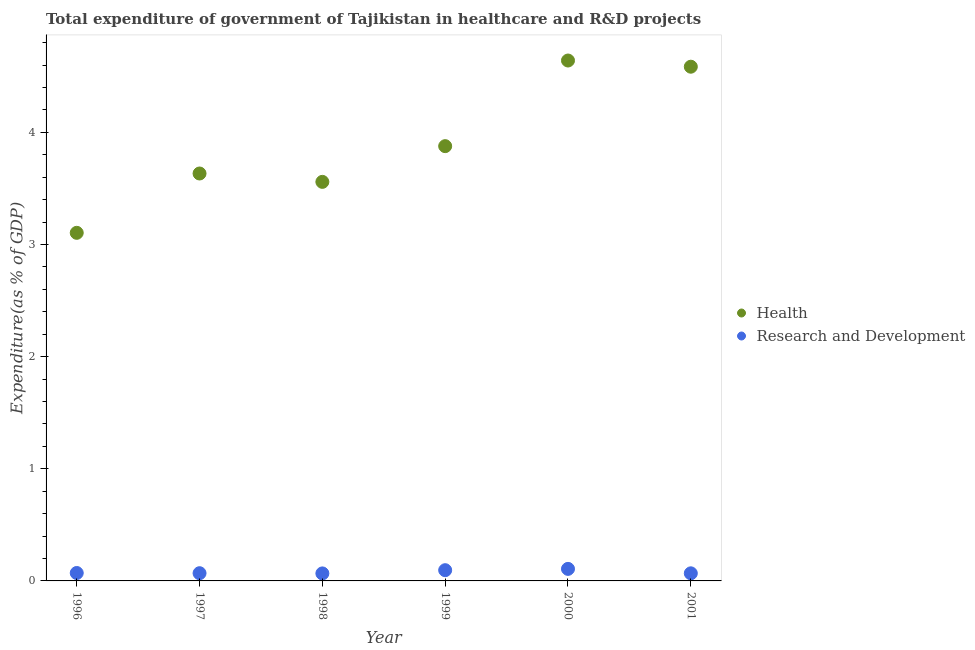Is the number of dotlines equal to the number of legend labels?
Ensure brevity in your answer.  Yes. What is the expenditure in healthcare in 1999?
Your answer should be very brief. 3.88. Across all years, what is the maximum expenditure in healthcare?
Provide a succinct answer. 4.64. Across all years, what is the minimum expenditure in healthcare?
Offer a very short reply. 3.1. In which year was the expenditure in healthcare maximum?
Your answer should be very brief. 2000. What is the total expenditure in healthcare in the graph?
Your answer should be very brief. 23.4. What is the difference between the expenditure in healthcare in 1997 and that in 1999?
Your answer should be very brief. -0.24. What is the difference between the expenditure in healthcare in 2001 and the expenditure in r&d in 2000?
Make the answer very short. 4.48. What is the average expenditure in r&d per year?
Keep it short and to the point. 0.08. In the year 2000, what is the difference between the expenditure in healthcare and expenditure in r&d?
Provide a succinct answer. 4.53. In how many years, is the expenditure in r&d greater than 2 %?
Offer a terse response. 0. What is the ratio of the expenditure in r&d in 1997 to that in 2000?
Your answer should be very brief. 0.64. What is the difference between the highest and the second highest expenditure in healthcare?
Offer a very short reply. 0.06. What is the difference between the highest and the lowest expenditure in healthcare?
Your response must be concise. 1.54. In how many years, is the expenditure in healthcare greater than the average expenditure in healthcare taken over all years?
Offer a terse response. 2. What is the difference between two consecutive major ticks on the Y-axis?
Keep it short and to the point. 1. Does the graph contain grids?
Your response must be concise. No. How many legend labels are there?
Keep it short and to the point. 2. How are the legend labels stacked?
Your response must be concise. Vertical. What is the title of the graph?
Provide a short and direct response. Total expenditure of government of Tajikistan in healthcare and R&D projects. Does "Lowest 20% of population" appear as one of the legend labels in the graph?
Make the answer very short. No. What is the label or title of the Y-axis?
Your answer should be compact. Expenditure(as % of GDP). What is the Expenditure(as % of GDP) of Health in 1996?
Give a very brief answer. 3.1. What is the Expenditure(as % of GDP) of Research and Development in 1996?
Provide a succinct answer. 0.07. What is the Expenditure(as % of GDP) in Health in 1997?
Offer a terse response. 3.63. What is the Expenditure(as % of GDP) in Research and Development in 1997?
Offer a very short reply. 0.07. What is the Expenditure(as % of GDP) in Health in 1998?
Keep it short and to the point. 3.56. What is the Expenditure(as % of GDP) in Research and Development in 1998?
Ensure brevity in your answer.  0.07. What is the Expenditure(as % of GDP) of Health in 1999?
Your answer should be compact. 3.88. What is the Expenditure(as % of GDP) in Research and Development in 1999?
Ensure brevity in your answer.  0.1. What is the Expenditure(as % of GDP) in Health in 2000?
Make the answer very short. 4.64. What is the Expenditure(as % of GDP) in Research and Development in 2000?
Provide a short and direct response. 0.11. What is the Expenditure(as % of GDP) of Health in 2001?
Make the answer very short. 4.59. What is the Expenditure(as % of GDP) in Research and Development in 2001?
Your answer should be compact. 0.07. Across all years, what is the maximum Expenditure(as % of GDP) of Health?
Ensure brevity in your answer.  4.64. Across all years, what is the maximum Expenditure(as % of GDP) of Research and Development?
Provide a succinct answer. 0.11. Across all years, what is the minimum Expenditure(as % of GDP) in Health?
Give a very brief answer. 3.1. Across all years, what is the minimum Expenditure(as % of GDP) in Research and Development?
Your answer should be very brief. 0.07. What is the total Expenditure(as % of GDP) in Health in the graph?
Keep it short and to the point. 23.4. What is the total Expenditure(as % of GDP) in Research and Development in the graph?
Make the answer very short. 0.48. What is the difference between the Expenditure(as % of GDP) of Health in 1996 and that in 1997?
Your answer should be very brief. -0.53. What is the difference between the Expenditure(as % of GDP) in Research and Development in 1996 and that in 1997?
Your answer should be compact. 0. What is the difference between the Expenditure(as % of GDP) in Health in 1996 and that in 1998?
Keep it short and to the point. -0.45. What is the difference between the Expenditure(as % of GDP) in Research and Development in 1996 and that in 1998?
Your answer should be very brief. 0. What is the difference between the Expenditure(as % of GDP) in Health in 1996 and that in 1999?
Your response must be concise. -0.77. What is the difference between the Expenditure(as % of GDP) in Research and Development in 1996 and that in 1999?
Provide a succinct answer. -0.03. What is the difference between the Expenditure(as % of GDP) in Health in 1996 and that in 2000?
Give a very brief answer. -1.54. What is the difference between the Expenditure(as % of GDP) in Research and Development in 1996 and that in 2000?
Ensure brevity in your answer.  -0.04. What is the difference between the Expenditure(as % of GDP) of Health in 1996 and that in 2001?
Your answer should be compact. -1.48. What is the difference between the Expenditure(as % of GDP) in Research and Development in 1996 and that in 2001?
Give a very brief answer. 0. What is the difference between the Expenditure(as % of GDP) of Health in 1997 and that in 1998?
Ensure brevity in your answer.  0.07. What is the difference between the Expenditure(as % of GDP) of Research and Development in 1997 and that in 1998?
Keep it short and to the point. 0. What is the difference between the Expenditure(as % of GDP) of Health in 1997 and that in 1999?
Ensure brevity in your answer.  -0.24. What is the difference between the Expenditure(as % of GDP) of Research and Development in 1997 and that in 1999?
Provide a short and direct response. -0.03. What is the difference between the Expenditure(as % of GDP) of Health in 1997 and that in 2000?
Provide a succinct answer. -1.01. What is the difference between the Expenditure(as % of GDP) in Research and Development in 1997 and that in 2000?
Keep it short and to the point. -0.04. What is the difference between the Expenditure(as % of GDP) of Health in 1997 and that in 2001?
Ensure brevity in your answer.  -0.95. What is the difference between the Expenditure(as % of GDP) of Research and Development in 1997 and that in 2001?
Your answer should be compact. 0. What is the difference between the Expenditure(as % of GDP) of Health in 1998 and that in 1999?
Give a very brief answer. -0.32. What is the difference between the Expenditure(as % of GDP) of Research and Development in 1998 and that in 1999?
Your answer should be very brief. -0.03. What is the difference between the Expenditure(as % of GDP) in Health in 1998 and that in 2000?
Offer a very short reply. -1.08. What is the difference between the Expenditure(as % of GDP) in Research and Development in 1998 and that in 2000?
Give a very brief answer. -0.04. What is the difference between the Expenditure(as % of GDP) of Health in 1998 and that in 2001?
Ensure brevity in your answer.  -1.03. What is the difference between the Expenditure(as % of GDP) in Research and Development in 1998 and that in 2001?
Provide a short and direct response. -0. What is the difference between the Expenditure(as % of GDP) of Health in 1999 and that in 2000?
Your answer should be compact. -0.76. What is the difference between the Expenditure(as % of GDP) of Research and Development in 1999 and that in 2000?
Offer a very short reply. -0.01. What is the difference between the Expenditure(as % of GDP) of Health in 1999 and that in 2001?
Keep it short and to the point. -0.71. What is the difference between the Expenditure(as % of GDP) in Research and Development in 1999 and that in 2001?
Make the answer very short. 0.03. What is the difference between the Expenditure(as % of GDP) of Health in 2000 and that in 2001?
Offer a very short reply. 0.06. What is the difference between the Expenditure(as % of GDP) in Research and Development in 2000 and that in 2001?
Provide a succinct answer. 0.04. What is the difference between the Expenditure(as % of GDP) in Health in 1996 and the Expenditure(as % of GDP) in Research and Development in 1997?
Provide a short and direct response. 3.04. What is the difference between the Expenditure(as % of GDP) of Health in 1996 and the Expenditure(as % of GDP) of Research and Development in 1998?
Your answer should be very brief. 3.04. What is the difference between the Expenditure(as % of GDP) in Health in 1996 and the Expenditure(as % of GDP) in Research and Development in 1999?
Ensure brevity in your answer.  3.01. What is the difference between the Expenditure(as % of GDP) of Health in 1996 and the Expenditure(as % of GDP) of Research and Development in 2000?
Make the answer very short. 3. What is the difference between the Expenditure(as % of GDP) of Health in 1996 and the Expenditure(as % of GDP) of Research and Development in 2001?
Ensure brevity in your answer.  3.04. What is the difference between the Expenditure(as % of GDP) in Health in 1997 and the Expenditure(as % of GDP) in Research and Development in 1998?
Ensure brevity in your answer.  3.57. What is the difference between the Expenditure(as % of GDP) in Health in 1997 and the Expenditure(as % of GDP) in Research and Development in 1999?
Keep it short and to the point. 3.54. What is the difference between the Expenditure(as % of GDP) of Health in 1997 and the Expenditure(as % of GDP) of Research and Development in 2000?
Provide a succinct answer. 3.53. What is the difference between the Expenditure(as % of GDP) of Health in 1997 and the Expenditure(as % of GDP) of Research and Development in 2001?
Your answer should be compact. 3.57. What is the difference between the Expenditure(as % of GDP) in Health in 1998 and the Expenditure(as % of GDP) in Research and Development in 1999?
Offer a very short reply. 3.46. What is the difference between the Expenditure(as % of GDP) in Health in 1998 and the Expenditure(as % of GDP) in Research and Development in 2000?
Make the answer very short. 3.45. What is the difference between the Expenditure(as % of GDP) in Health in 1998 and the Expenditure(as % of GDP) in Research and Development in 2001?
Provide a succinct answer. 3.49. What is the difference between the Expenditure(as % of GDP) of Health in 1999 and the Expenditure(as % of GDP) of Research and Development in 2000?
Make the answer very short. 3.77. What is the difference between the Expenditure(as % of GDP) of Health in 1999 and the Expenditure(as % of GDP) of Research and Development in 2001?
Make the answer very short. 3.81. What is the difference between the Expenditure(as % of GDP) of Health in 2000 and the Expenditure(as % of GDP) of Research and Development in 2001?
Offer a terse response. 4.57. What is the average Expenditure(as % of GDP) of Health per year?
Your answer should be compact. 3.9. What is the average Expenditure(as % of GDP) in Research and Development per year?
Provide a short and direct response. 0.08. In the year 1996, what is the difference between the Expenditure(as % of GDP) of Health and Expenditure(as % of GDP) of Research and Development?
Offer a terse response. 3.03. In the year 1997, what is the difference between the Expenditure(as % of GDP) of Health and Expenditure(as % of GDP) of Research and Development?
Provide a succinct answer. 3.56. In the year 1998, what is the difference between the Expenditure(as % of GDP) in Health and Expenditure(as % of GDP) in Research and Development?
Keep it short and to the point. 3.49. In the year 1999, what is the difference between the Expenditure(as % of GDP) of Health and Expenditure(as % of GDP) of Research and Development?
Your response must be concise. 3.78. In the year 2000, what is the difference between the Expenditure(as % of GDP) of Health and Expenditure(as % of GDP) of Research and Development?
Your answer should be very brief. 4.53. In the year 2001, what is the difference between the Expenditure(as % of GDP) in Health and Expenditure(as % of GDP) in Research and Development?
Offer a terse response. 4.52. What is the ratio of the Expenditure(as % of GDP) in Health in 1996 to that in 1997?
Give a very brief answer. 0.85. What is the ratio of the Expenditure(as % of GDP) of Research and Development in 1996 to that in 1997?
Your answer should be compact. 1.03. What is the ratio of the Expenditure(as % of GDP) in Health in 1996 to that in 1998?
Your answer should be compact. 0.87. What is the ratio of the Expenditure(as % of GDP) in Research and Development in 1996 to that in 1998?
Provide a short and direct response. 1.06. What is the ratio of the Expenditure(as % of GDP) in Health in 1996 to that in 1999?
Your answer should be very brief. 0.8. What is the ratio of the Expenditure(as % of GDP) of Research and Development in 1996 to that in 1999?
Give a very brief answer. 0.74. What is the ratio of the Expenditure(as % of GDP) in Health in 1996 to that in 2000?
Your answer should be very brief. 0.67. What is the ratio of the Expenditure(as % of GDP) in Research and Development in 1996 to that in 2000?
Your response must be concise. 0.66. What is the ratio of the Expenditure(as % of GDP) of Health in 1996 to that in 2001?
Ensure brevity in your answer.  0.68. What is the ratio of the Expenditure(as % of GDP) in Research and Development in 1996 to that in 2001?
Offer a very short reply. 1.04. What is the ratio of the Expenditure(as % of GDP) in Research and Development in 1997 to that in 1998?
Ensure brevity in your answer.  1.03. What is the ratio of the Expenditure(as % of GDP) in Health in 1997 to that in 1999?
Offer a very short reply. 0.94. What is the ratio of the Expenditure(as % of GDP) of Research and Development in 1997 to that in 1999?
Your response must be concise. 0.72. What is the ratio of the Expenditure(as % of GDP) in Health in 1997 to that in 2000?
Ensure brevity in your answer.  0.78. What is the ratio of the Expenditure(as % of GDP) in Research and Development in 1997 to that in 2000?
Your response must be concise. 0.64. What is the ratio of the Expenditure(as % of GDP) of Health in 1997 to that in 2001?
Ensure brevity in your answer.  0.79. What is the ratio of the Expenditure(as % of GDP) in Research and Development in 1997 to that in 2001?
Provide a short and direct response. 1.02. What is the ratio of the Expenditure(as % of GDP) of Health in 1998 to that in 1999?
Give a very brief answer. 0.92. What is the ratio of the Expenditure(as % of GDP) of Research and Development in 1998 to that in 1999?
Your answer should be compact. 0.7. What is the ratio of the Expenditure(as % of GDP) of Health in 1998 to that in 2000?
Ensure brevity in your answer.  0.77. What is the ratio of the Expenditure(as % of GDP) of Research and Development in 1998 to that in 2000?
Offer a terse response. 0.62. What is the ratio of the Expenditure(as % of GDP) in Health in 1998 to that in 2001?
Offer a terse response. 0.78. What is the ratio of the Expenditure(as % of GDP) of Research and Development in 1998 to that in 2001?
Give a very brief answer. 0.99. What is the ratio of the Expenditure(as % of GDP) of Health in 1999 to that in 2000?
Ensure brevity in your answer.  0.84. What is the ratio of the Expenditure(as % of GDP) in Research and Development in 1999 to that in 2000?
Provide a short and direct response. 0.89. What is the ratio of the Expenditure(as % of GDP) of Health in 1999 to that in 2001?
Make the answer very short. 0.85. What is the ratio of the Expenditure(as % of GDP) of Research and Development in 1999 to that in 2001?
Ensure brevity in your answer.  1.41. What is the ratio of the Expenditure(as % of GDP) of Research and Development in 2000 to that in 2001?
Make the answer very short. 1.58. What is the difference between the highest and the second highest Expenditure(as % of GDP) in Health?
Make the answer very short. 0.06. What is the difference between the highest and the second highest Expenditure(as % of GDP) of Research and Development?
Offer a terse response. 0.01. What is the difference between the highest and the lowest Expenditure(as % of GDP) of Health?
Provide a succinct answer. 1.54. What is the difference between the highest and the lowest Expenditure(as % of GDP) in Research and Development?
Ensure brevity in your answer.  0.04. 